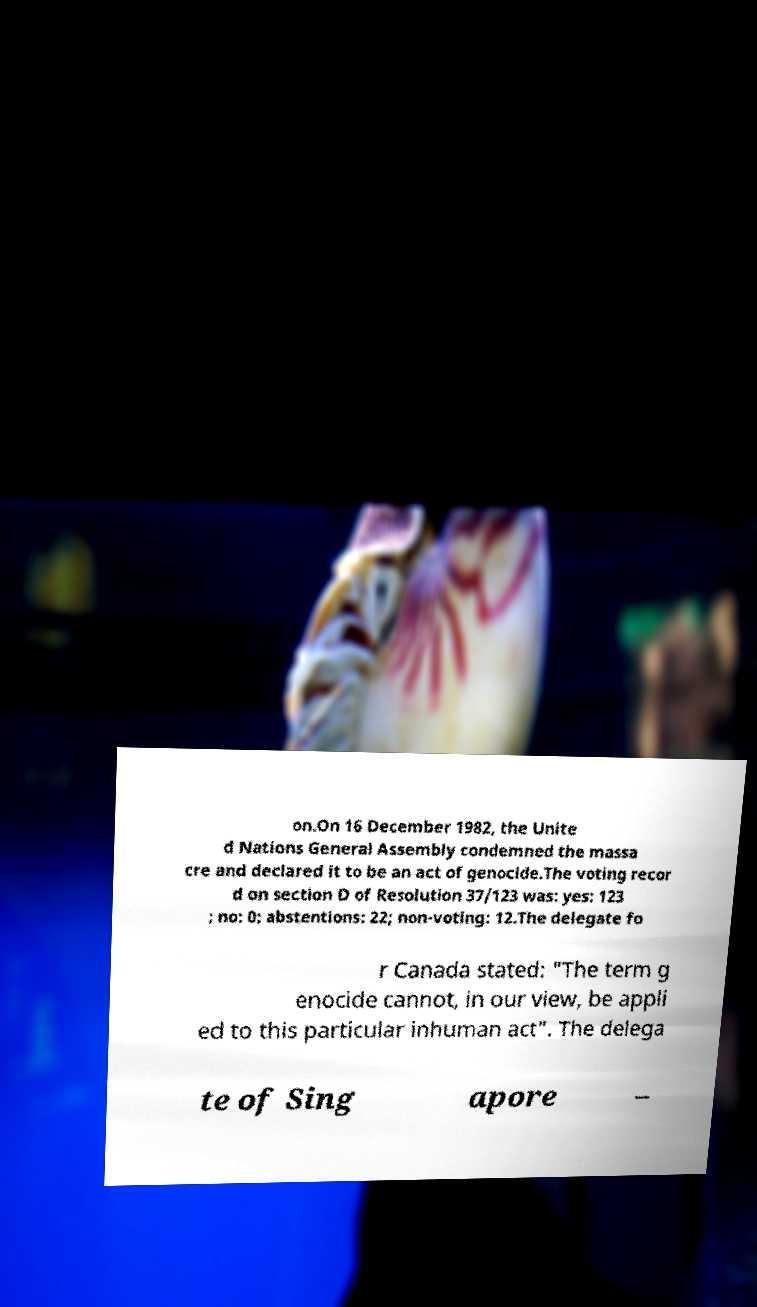Please identify and transcribe the text found in this image. on.On 16 December 1982, the Unite d Nations General Assembly condemned the massa cre and declared it to be an act of genocide.The voting recor d on section D of Resolution 37/123 was: yes: 123 ; no: 0; abstentions: 22; non-voting: 12.The delegate fo r Canada stated: "The term g enocide cannot, in our view, be appli ed to this particular inhuman act". The delega te of Sing apore – 